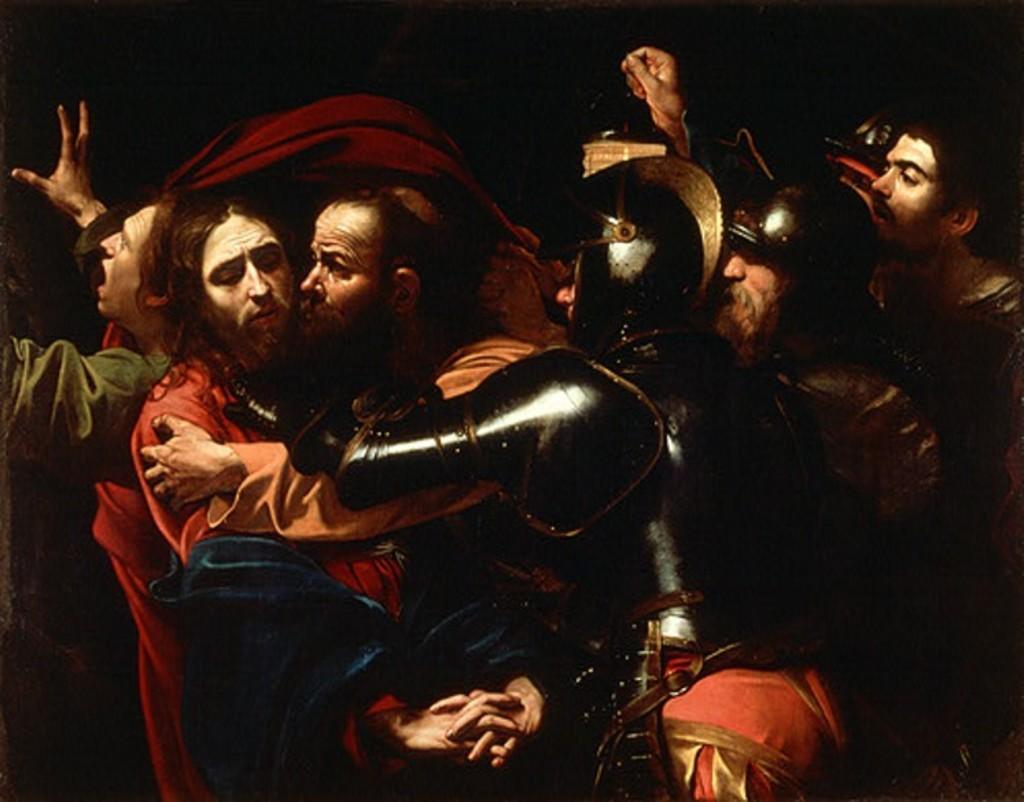Can you describe this image briefly? In this image there are group of men, there are three men wearing a helmet, the background of the image is dark. 